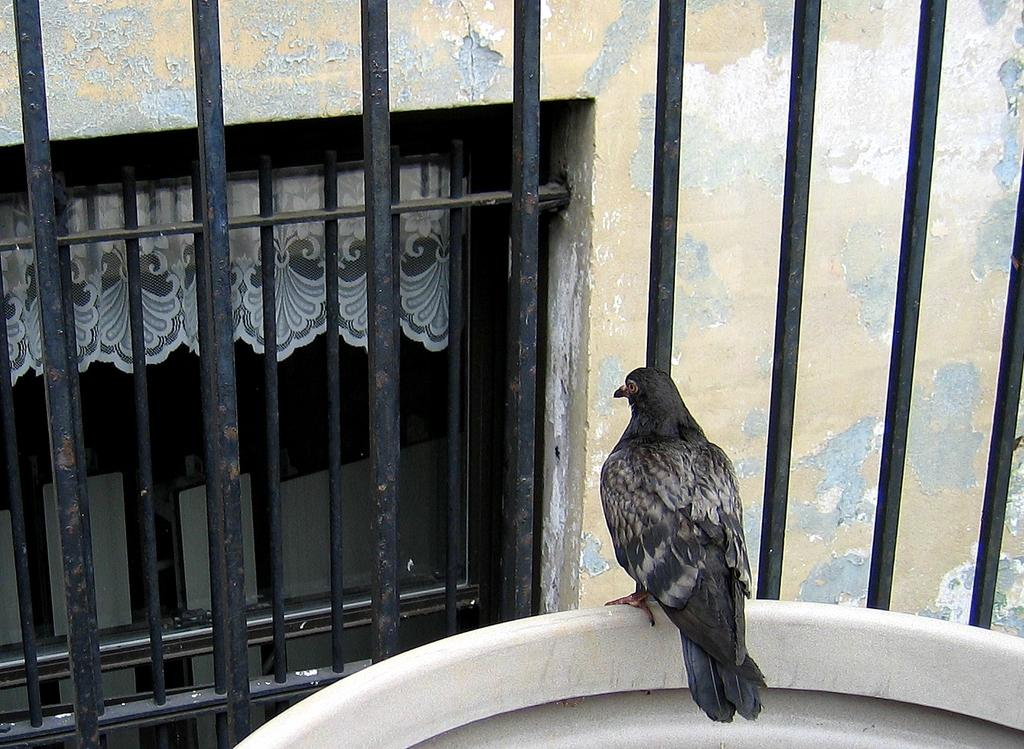What type of animal is in the image? There is a pigeon in the image. What is the pigeon doing in the image? The pigeon is standing on an object. What can be seen in the background of the image? There is a black fence in the image. What songs is the giraffe singing in the image? There is no giraffe present in the image, and therefore no songs can be heard. How many clams are visible on the pigeon's back in the image? There are no clams present in the image, and the pigeon is not carrying any clams on its back. 